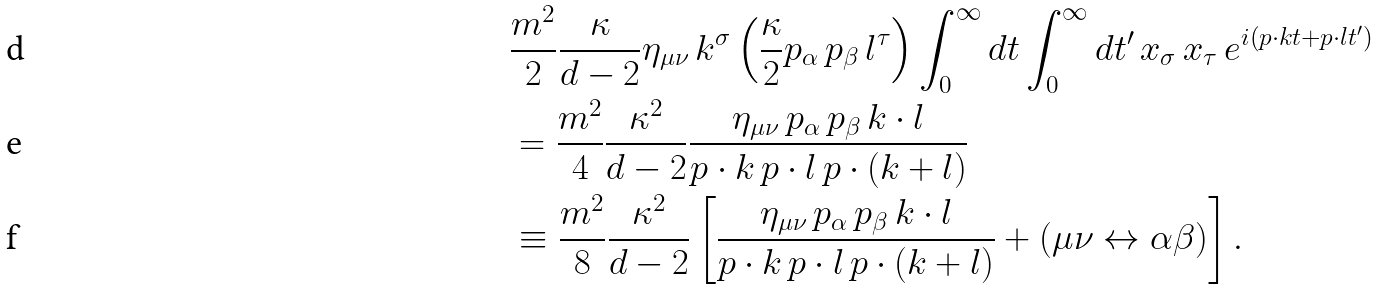<formula> <loc_0><loc_0><loc_500><loc_500>& \frac { m ^ { 2 } } { 2 } \frac { \kappa } { d - 2 } \eta _ { \mu \nu } \, k ^ { \sigma } \left ( \frac { \kappa } { 2 } p _ { \alpha } \, p _ { \beta } \, l ^ { \tau } \right ) \int _ { 0 } ^ { \infty } d t \int _ { 0 } ^ { \infty } d t ^ { \prime } \, x _ { \sigma } \, x _ { \tau } \, e ^ { i ( p \cdot k t + p \cdot l t ^ { \prime } ) } \\ & = \frac { m ^ { 2 } } { 4 } \frac { \kappa ^ { 2 } } { d - 2 } \frac { \eta _ { \mu \nu } \, p _ { \alpha } \, p _ { \beta } \, k \cdot l } { p \cdot k \, p \cdot l \, p \cdot ( k + l ) } \\ & \equiv \frac { m ^ { 2 } } { 8 } \frac { \kappa ^ { 2 } } { d - 2 } \left [ \frac { \eta _ { \mu \nu } \, p _ { \alpha } \, p _ { \beta } \, k \cdot l } { p \cdot k \, p \cdot l \, p \cdot ( k + l ) } + ( \mu \nu \leftrightarrow \alpha \beta ) \right ] .</formula> 